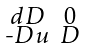<formula> <loc_0><loc_0><loc_500><loc_500>\begin{smallmatrix} d D & 0 \\ \text {-} D u & D \end{smallmatrix}</formula> 